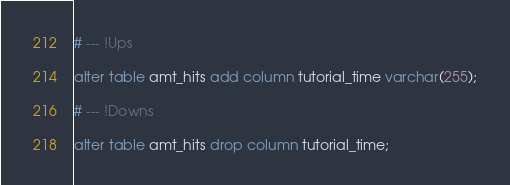<code> <loc_0><loc_0><loc_500><loc_500><_SQL_># --- !Ups

alter table amt_hits add column tutorial_time varchar(255);

# --- !Downs

alter table amt_hits drop column tutorial_time;
</code> 